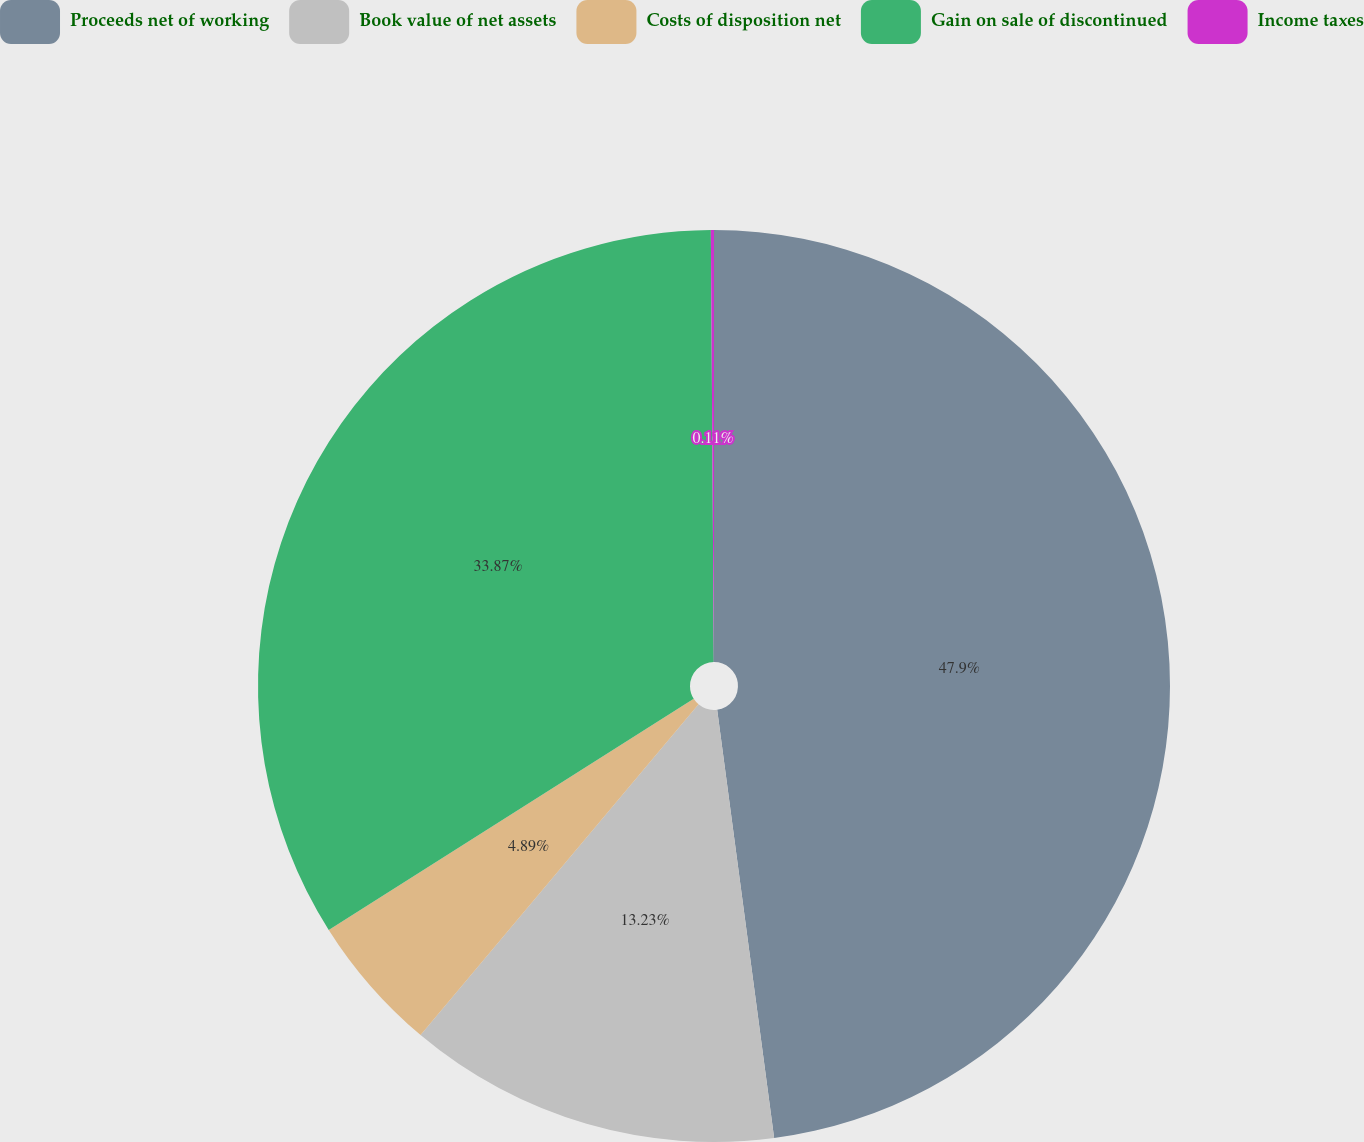Convert chart to OTSL. <chart><loc_0><loc_0><loc_500><loc_500><pie_chart><fcel>Proceeds net of working<fcel>Book value of net assets<fcel>Costs of disposition net<fcel>Gain on sale of discontinued<fcel>Income taxes<nl><fcel>47.89%<fcel>13.23%<fcel>4.89%<fcel>33.87%<fcel>0.11%<nl></chart> 